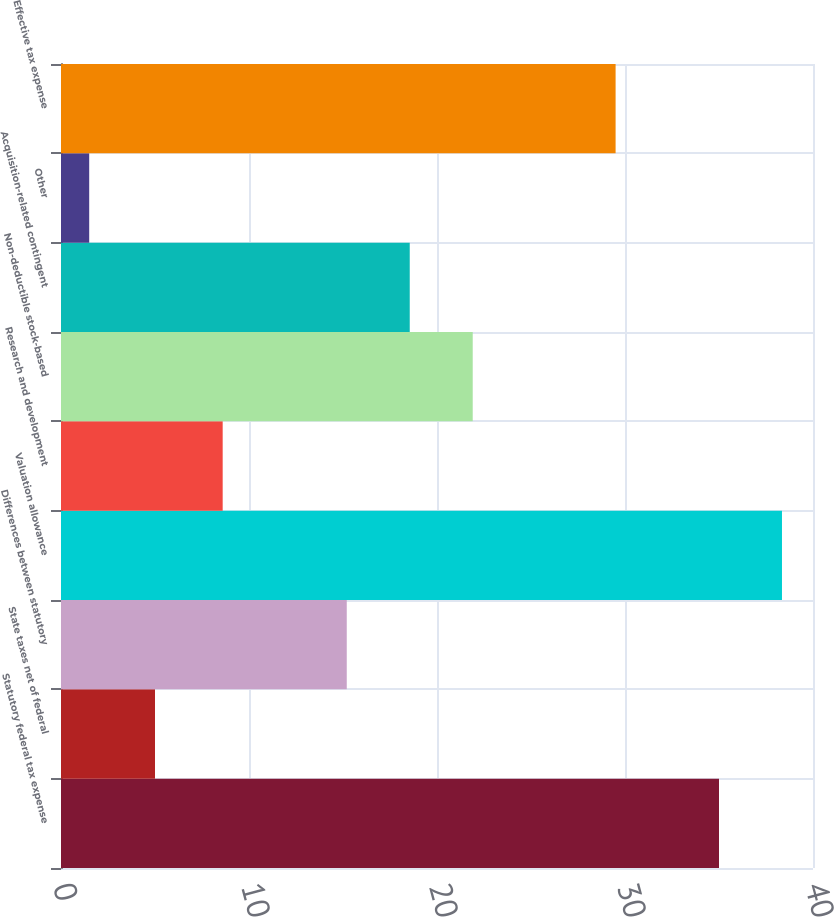Convert chart. <chart><loc_0><loc_0><loc_500><loc_500><bar_chart><fcel>Statutory federal tax expense<fcel>State taxes net of federal<fcel>Differences between statutory<fcel>Valuation allowance<fcel>Research and development<fcel>Non-deductible stock-based<fcel>Acquisition-related contingent<fcel>Other<fcel>Effective tax expense<nl><fcel>35<fcel>5<fcel>15.2<fcel>38.35<fcel>8.6<fcel>21.9<fcel>18.55<fcel>1.5<fcel>29.5<nl></chart> 